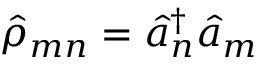<formula> <loc_0><loc_0><loc_500><loc_500>{ \hat { \rho } } _ { m n } = { \hat { a } } _ { n } ^ { \dagger } { \hat { a } } _ { m }</formula> 